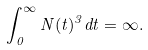<formula> <loc_0><loc_0><loc_500><loc_500>\int _ { 0 } ^ { \infty } N ( t ) ^ { 3 } d t = \infty .</formula> 